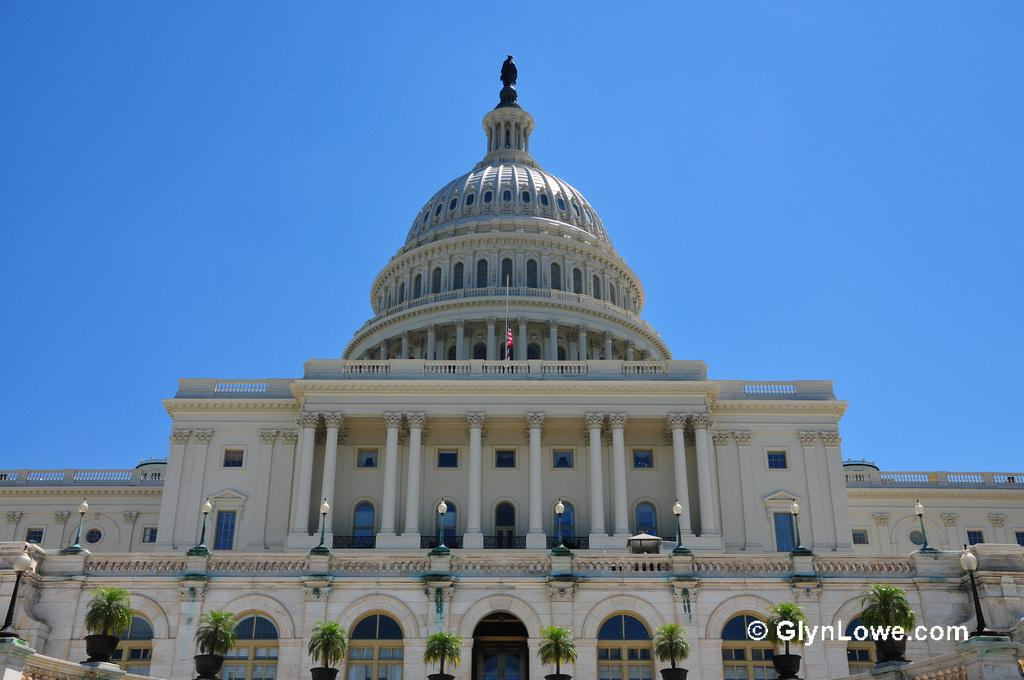What type of building is in the image? There is a palace in the image. What is located in front of the palace? There are plants in front of the palace. What is on top of the palace? There is a statue above the palace, and a flag is in the middle of the statue. What can be seen in the background of the image? The sky is visible in the background of the image. Where is the harbor located in the image? There is no harbor present in the image. What type of love is depicted in the statue above the palace? The image does not depict any love or emotion; it only shows a palace, plants, a statue, a flag, and the sky. 